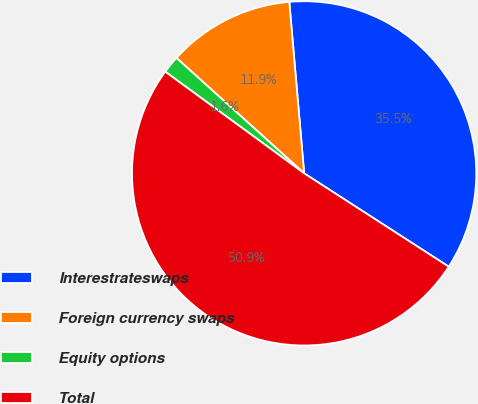<chart> <loc_0><loc_0><loc_500><loc_500><pie_chart><fcel>Interestrateswaps<fcel>Foreign currency swaps<fcel>Equity options<fcel>Total<nl><fcel>35.5%<fcel>11.93%<fcel>1.64%<fcel>50.93%<nl></chart> 